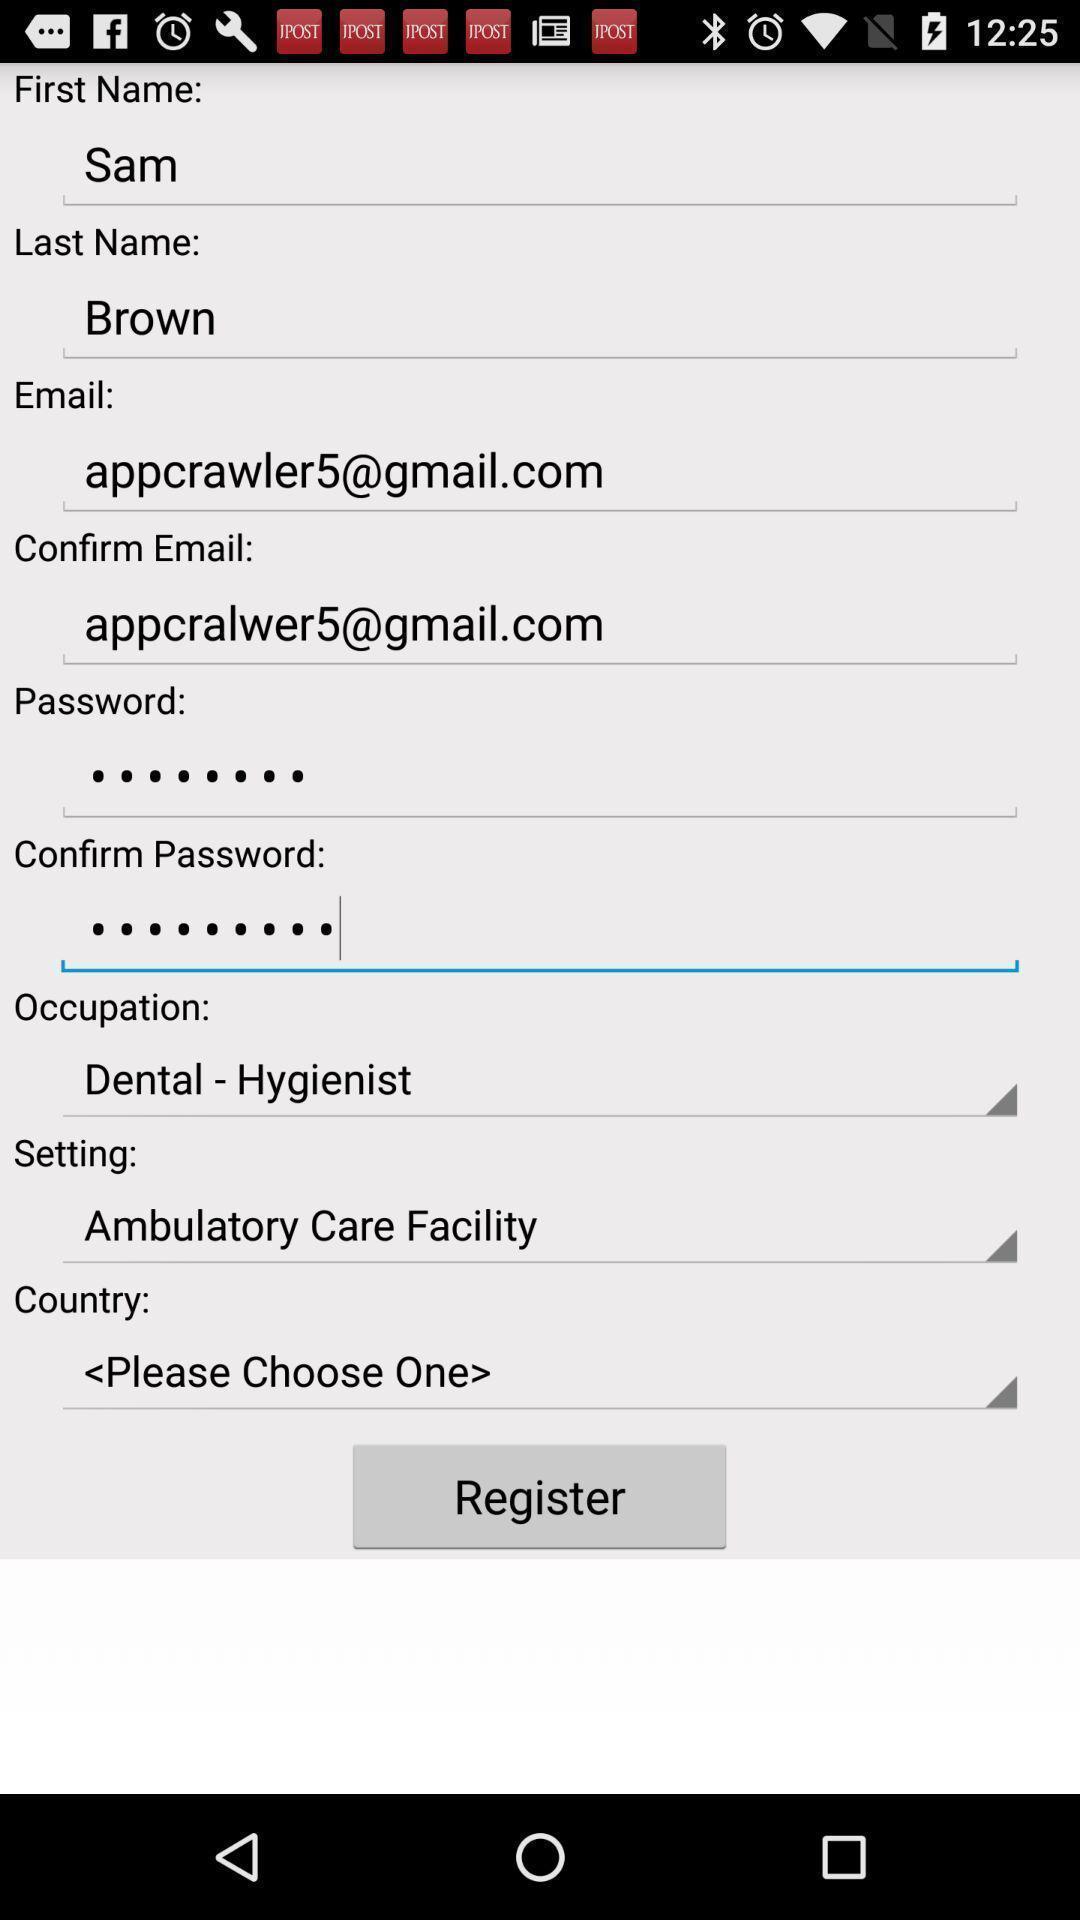Provide a detailed account of this screenshot. Screen shows to register with multiple details. 